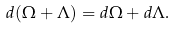Convert formula to latex. <formula><loc_0><loc_0><loc_500><loc_500>d ( { \Omega } + { \Lambda } ) = d { \Omega } + d { \Lambda } .</formula> 